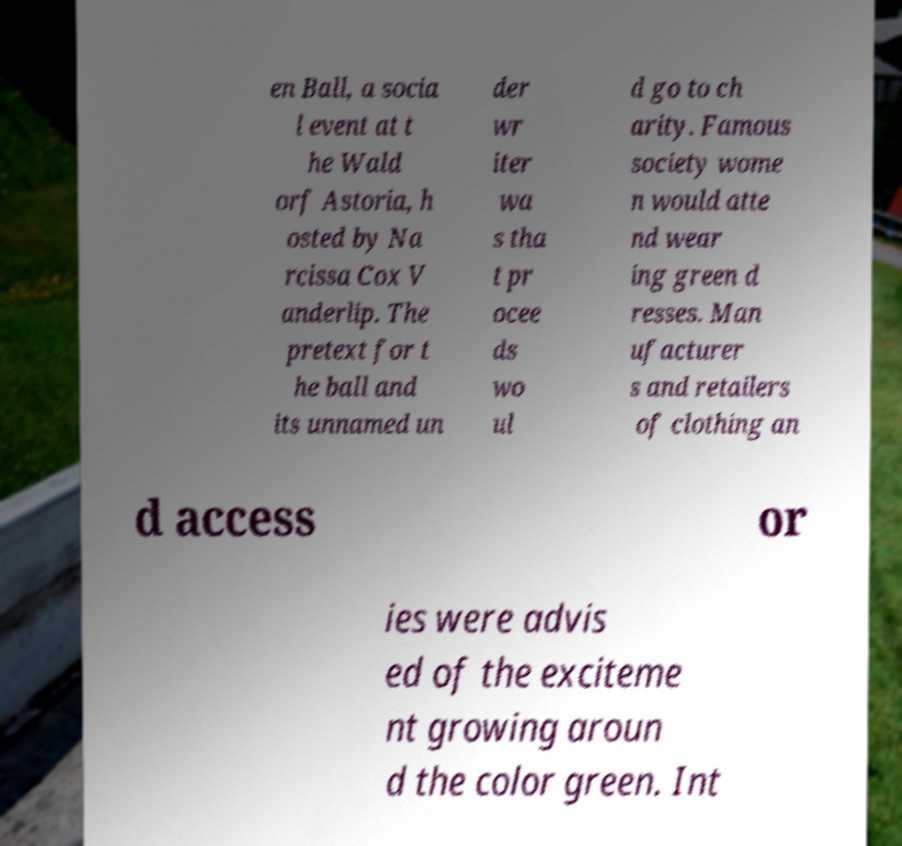I need the written content from this picture converted into text. Can you do that? en Ball, a socia l event at t he Wald orf Astoria, h osted by Na rcissa Cox V anderlip. The pretext for t he ball and its unnamed un der wr iter wa s tha t pr ocee ds wo ul d go to ch arity. Famous society wome n would atte nd wear ing green d resses. Man ufacturer s and retailers of clothing an d access or ies were advis ed of the exciteme nt growing aroun d the color green. Int 